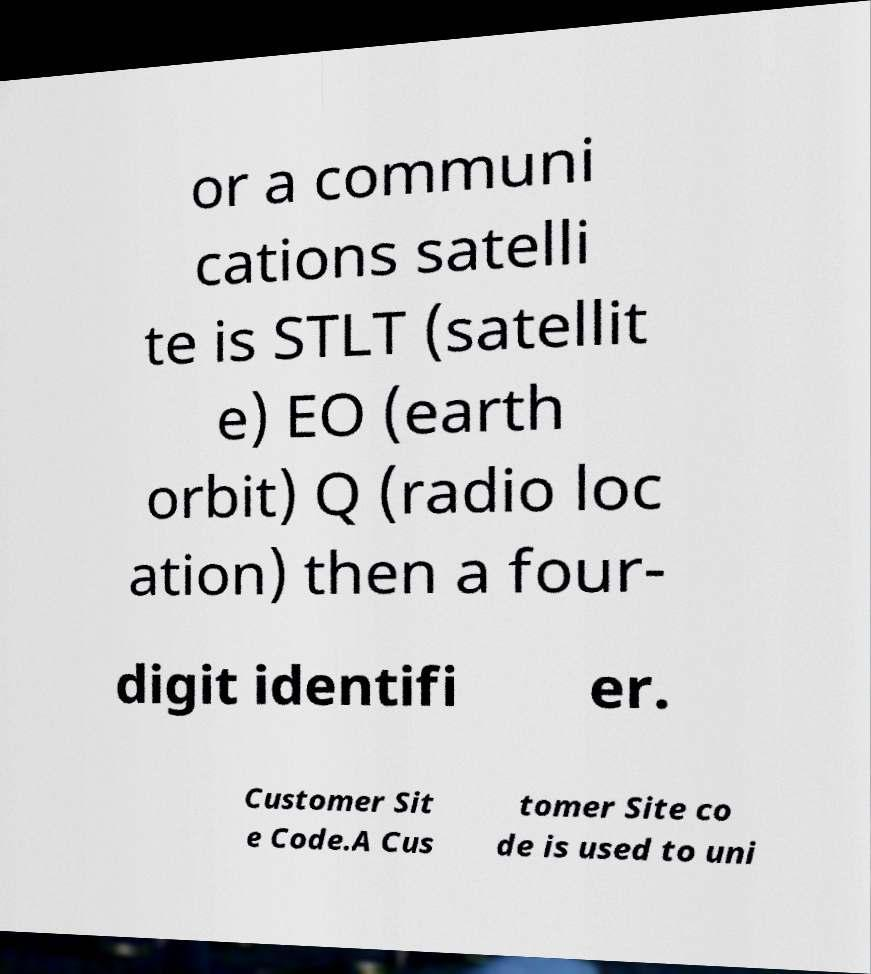Could you extract and type out the text from this image? or a communi cations satelli te is STLT (satellit e) EO (earth orbit) Q (radio loc ation) then a four- digit identifi er. Customer Sit e Code.A Cus tomer Site co de is used to uni 